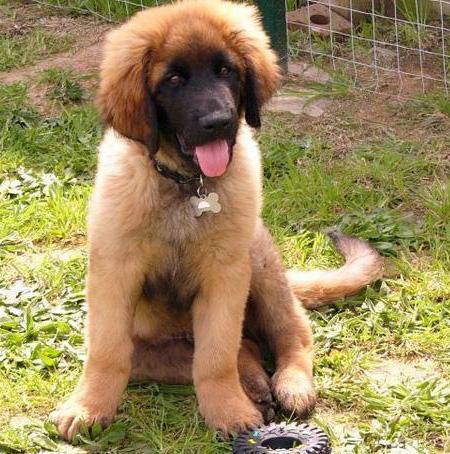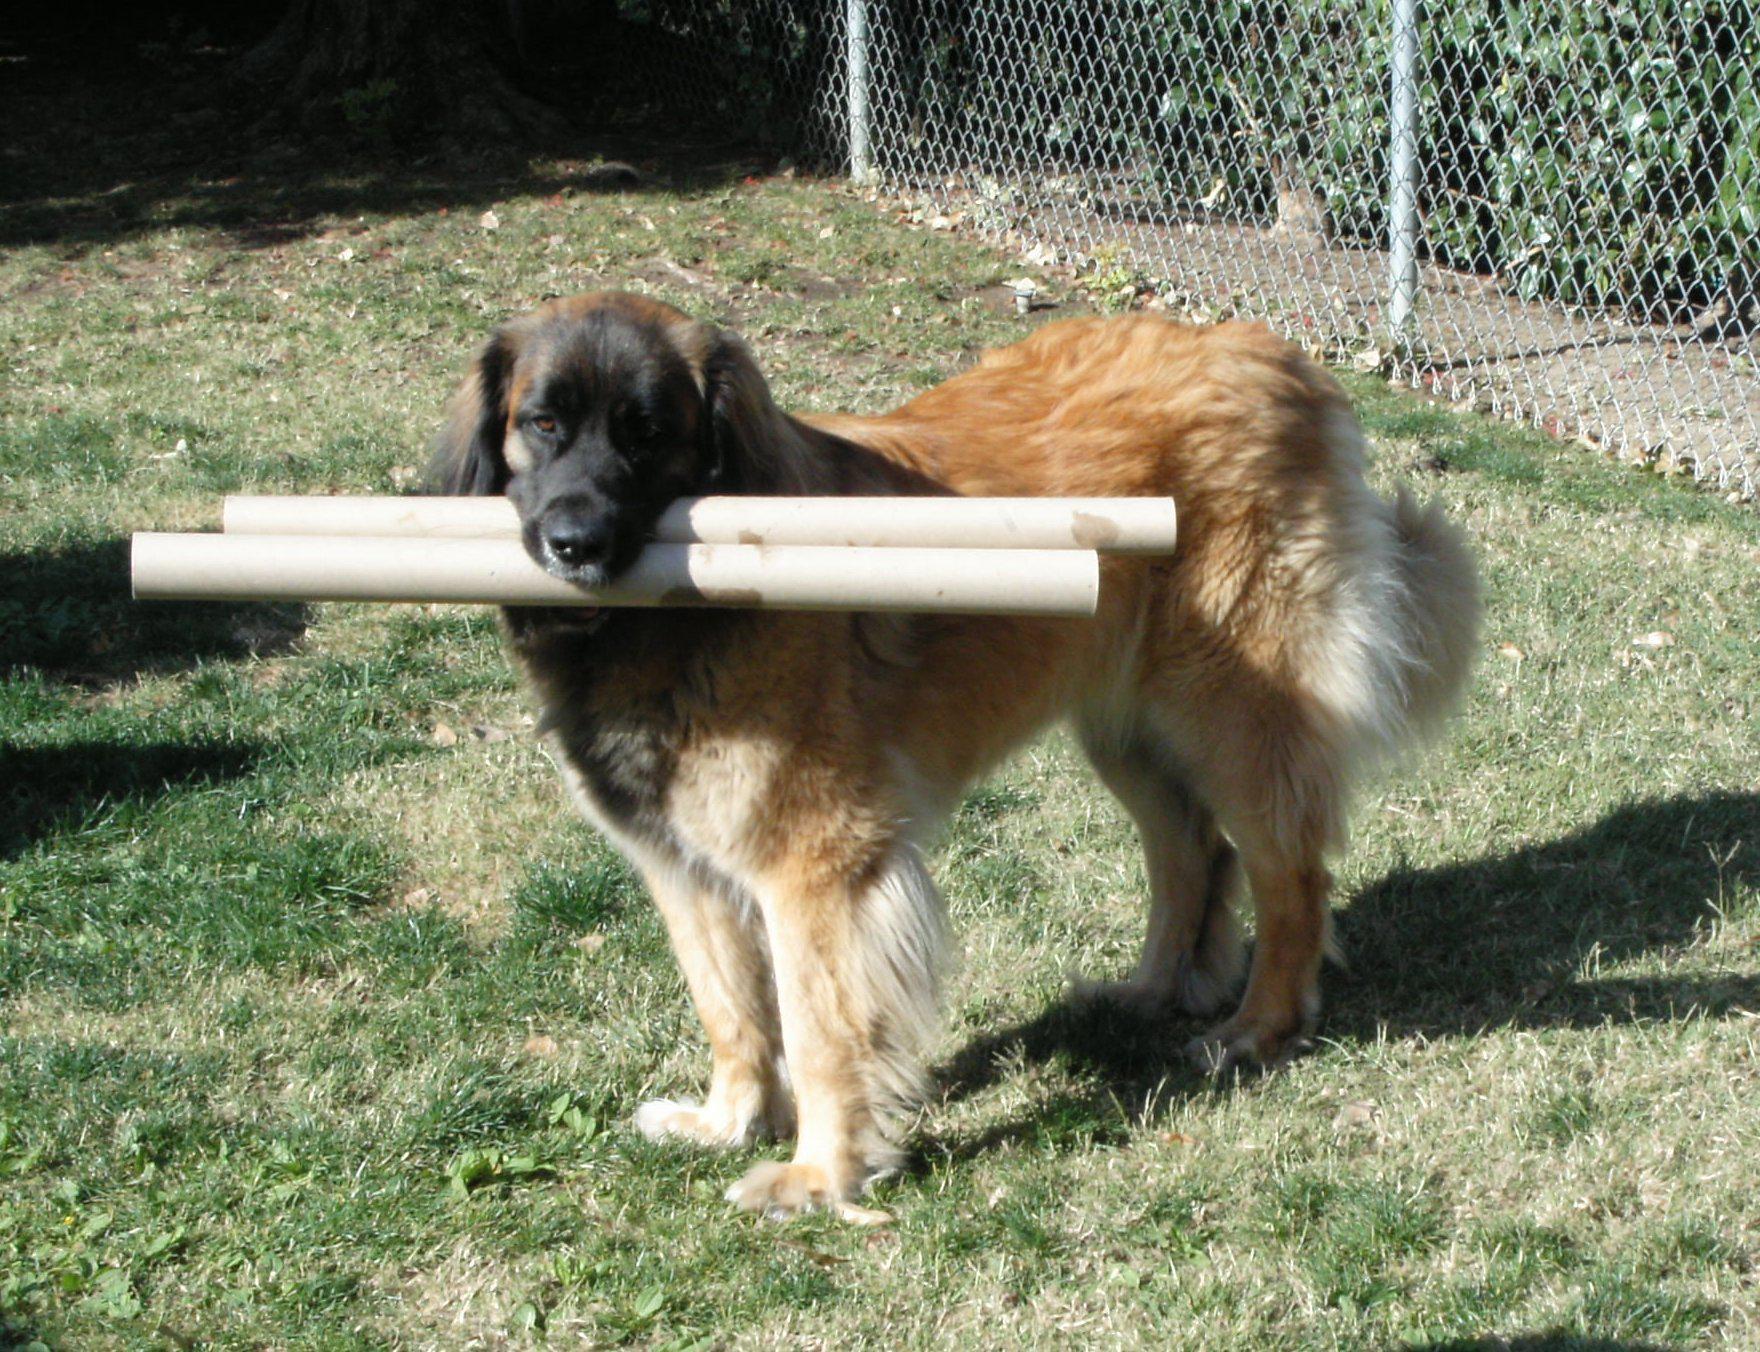The first image is the image on the left, the second image is the image on the right. Given the left and right images, does the statement "At least one of the dogs in the image on the left is shown standing up on the ground." hold true? Answer yes or no. No. The first image is the image on the left, the second image is the image on the right. Considering the images on both sides, is "One image contains just one dog, which is standing on all fours." valid? Answer yes or no. Yes. 